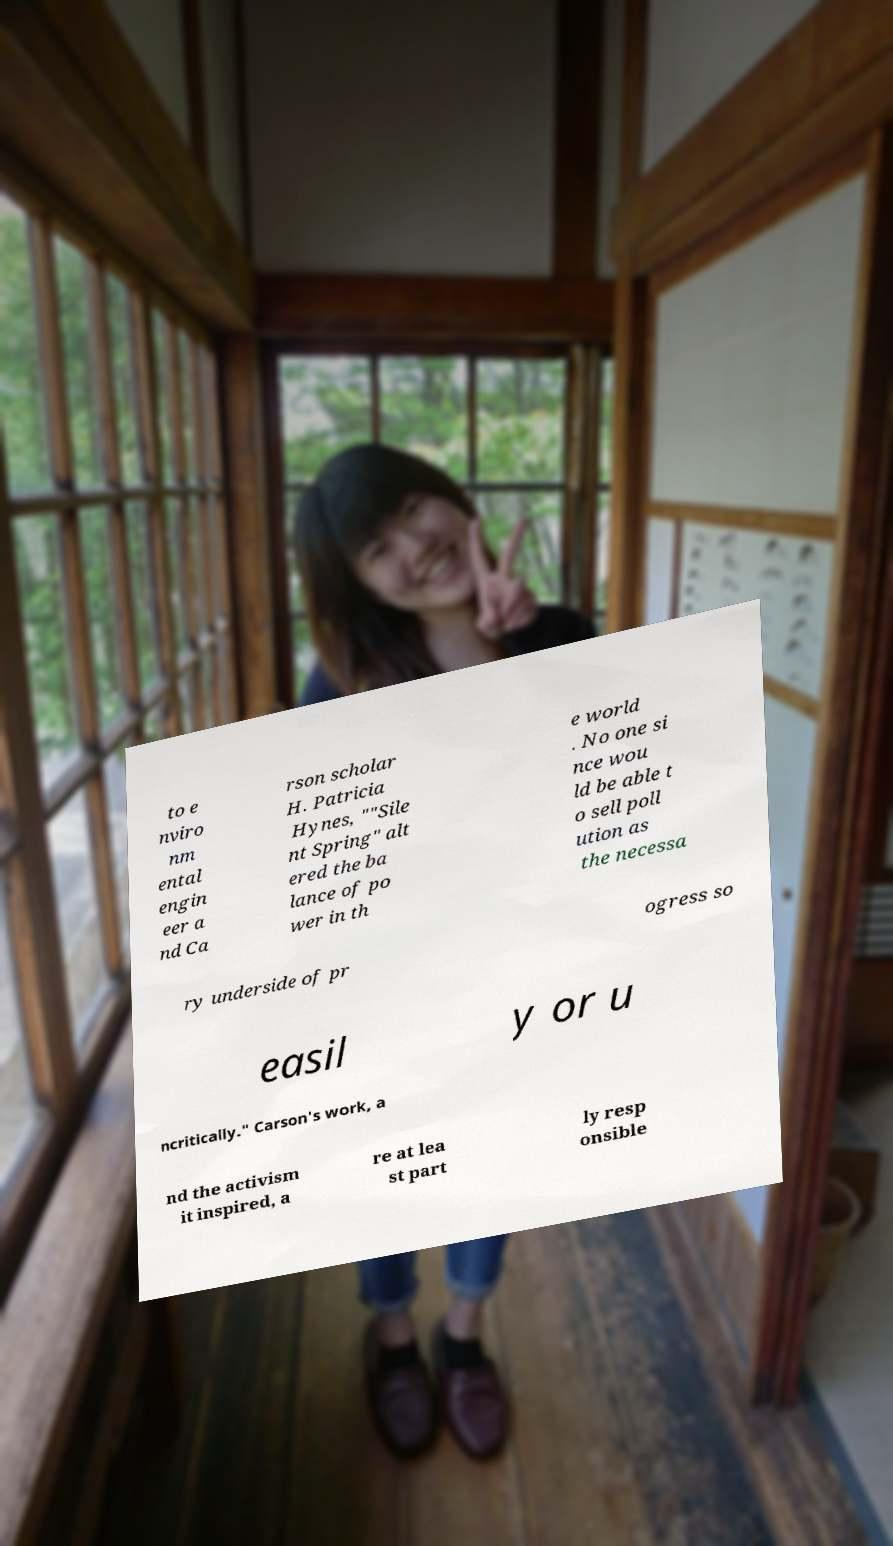Could you assist in decoding the text presented in this image and type it out clearly? to e nviro nm ental engin eer a nd Ca rson scholar H. Patricia Hynes, ""Sile nt Spring" alt ered the ba lance of po wer in th e world . No one si nce wou ld be able t o sell poll ution as the necessa ry underside of pr ogress so easil y or u ncritically." Carson's work, a nd the activism it inspired, a re at lea st part ly resp onsible 